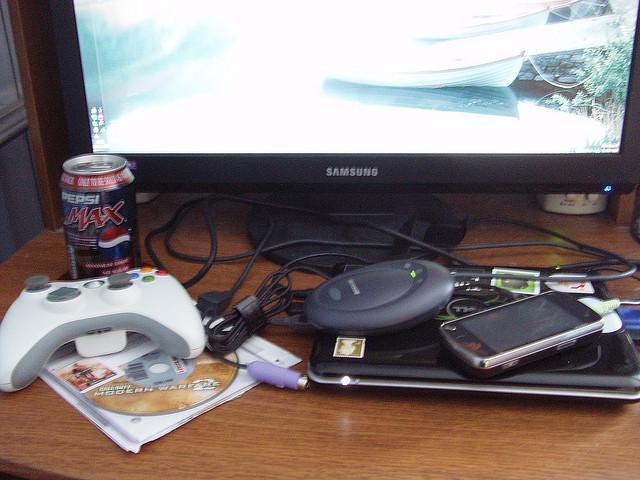How many cell phones are in the picture?
Give a very brief answer. 1. How many cups are on the table?
Give a very brief answer. 0. 